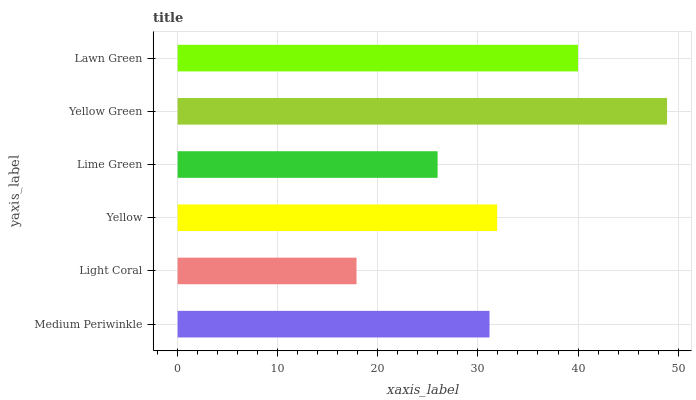Is Light Coral the minimum?
Answer yes or no. Yes. Is Yellow Green the maximum?
Answer yes or no. Yes. Is Yellow the minimum?
Answer yes or no. No. Is Yellow the maximum?
Answer yes or no. No. Is Yellow greater than Light Coral?
Answer yes or no. Yes. Is Light Coral less than Yellow?
Answer yes or no. Yes. Is Light Coral greater than Yellow?
Answer yes or no. No. Is Yellow less than Light Coral?
Answer yes or no. No. Is Yellow the high median?
Answer yes or no. Yes. Is Medium Periwinkle the low median?
Answer yes or no. Yes. Is Lawn Green the high median?
Answer yes or no. No. Is Lawn Green the low median?
Answer yes or no. No. 